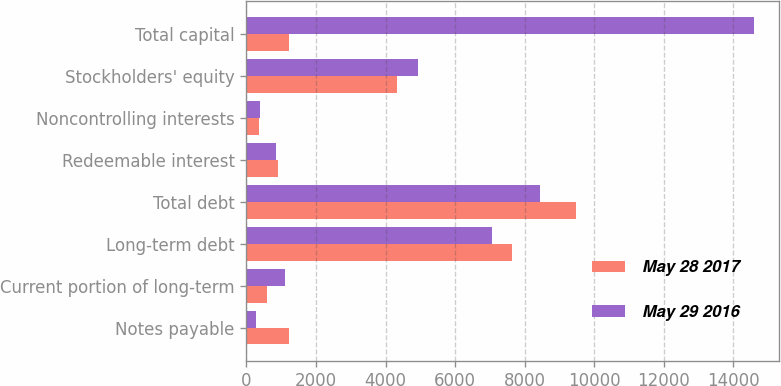Convert chart to OTSL. <chart><loc_0><loc_0><loc_500><loc_500><stacked_bar_chart><ecel><fcel>Notes payable<fcel>Current portion of long-term<fcel>Long-term debt<fcel>Total debt<fcel>Redeemable interest<fcel>Noncontrolling interests<fcel>Stockholders' equity<fcel>Total capital<nl><fcel>May 28 2017<fcel>1234.1<fcel>604.7<fcel>7642.9<fcel>9481.7<fcel>910.9<fcel>357.6<fcel>4327.9<fcel>1234.1<nl><fcel>May 29 2016<fcel>269.8<fcel>1103.4<fcel>7057.7<fcel>8430.9<fcel>845.6<fcel>376.9<fcel>4930.2<fcel>14583.6<nl></chart> 